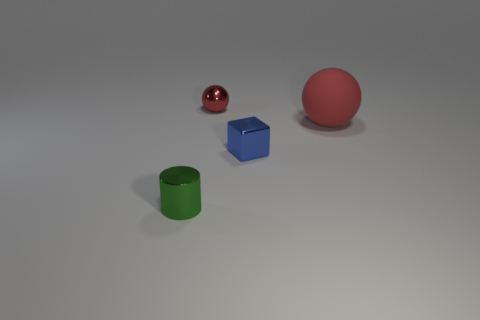What number of red metallic things have the same size as the green cylinder?
Ensure brevity in your answer.  1. There is a shiny object in front of the metal block; is it the same size as the sphere that is to the left of the big object?
Your answer should be compact. Yes. Are there more metallic cubes that are behind the red metallic thing than spheres in front of the large red sphere?
Your answer should be very brief. No. What number of large red things are the same shape as the tiny red metallic object?
Keep it short and to the point. 1. There is a blue thing that is the same size as the metallic ball; what is it made of?
Provide a succinct answer. Metal. Are there any large blue balls that have the same material as the small red ball?
Keep it short and to the point. No. Are there fewer small red shiny things that are left of the green cylinder than small blue blocks?
Your response must be concise. Yes. There is a tiny thing right of the small object behind the large matte object; what is its material?
Ensure brevity in your answer.  Metal. What is the shape of the small shiny object that is both in front of the tiny metallic sphere and behind the small metallic cylinder?
Make the answer very short. Cube. How many other things are there of the same color as the big rubber sphere?
Ensure brevity in your answer.  1. 